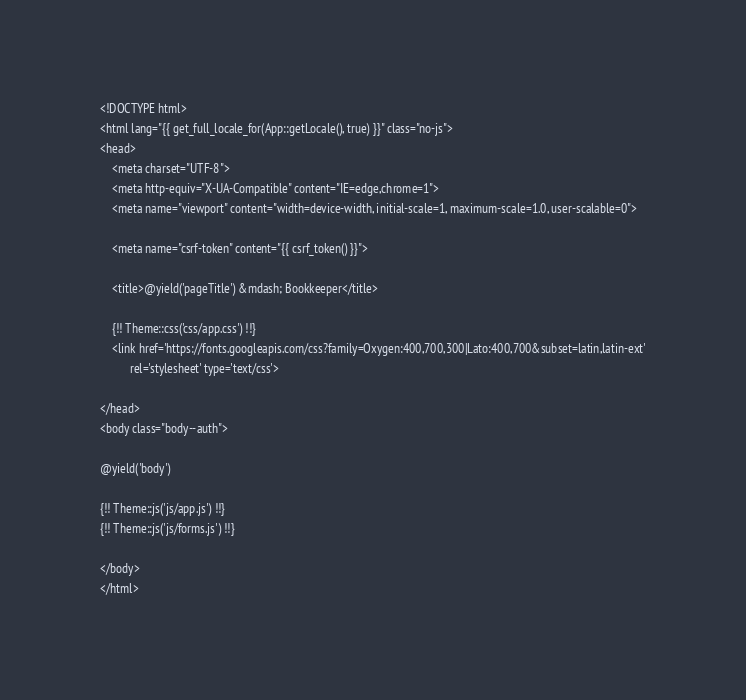Convert code to text. <code><loc_0><loc_0><loc_500><loc_500><_PHP_><!DOCTYPE html>
<html lang="{{ get_full_locale_for(App::getLocale(), true) }}" class="no-js">
<head>
    <meta charset="UTF-8">
    <meta http-equiv="X-UA-Compatible" content="IE=edge,chrome=1">
    <meta name="viewport" content="width=device-width, initial-scale=1, maximum-scale=1.0, user-scalable=0">

    <meta name="csrf-token" content="{{ csrf_token() }}">

    <title>@yield('pageTitle') &mdash; Bookkeeper</title>

    {!! Theme::css('css/app.css') !!}
    <link href='https://fonts.googleapis.com/css?family=Oxygen:400,700,300|Lato:400,700&subset=latin,latin-ext'
          rel='stylesheet' type='text/css'>

</head>
<body class="body--auth">

@yield('body')

{!! Theme::js('js/app.js') !!}
{!! Theme::js('js/forms.js') !!}

</body>
</html></code> 